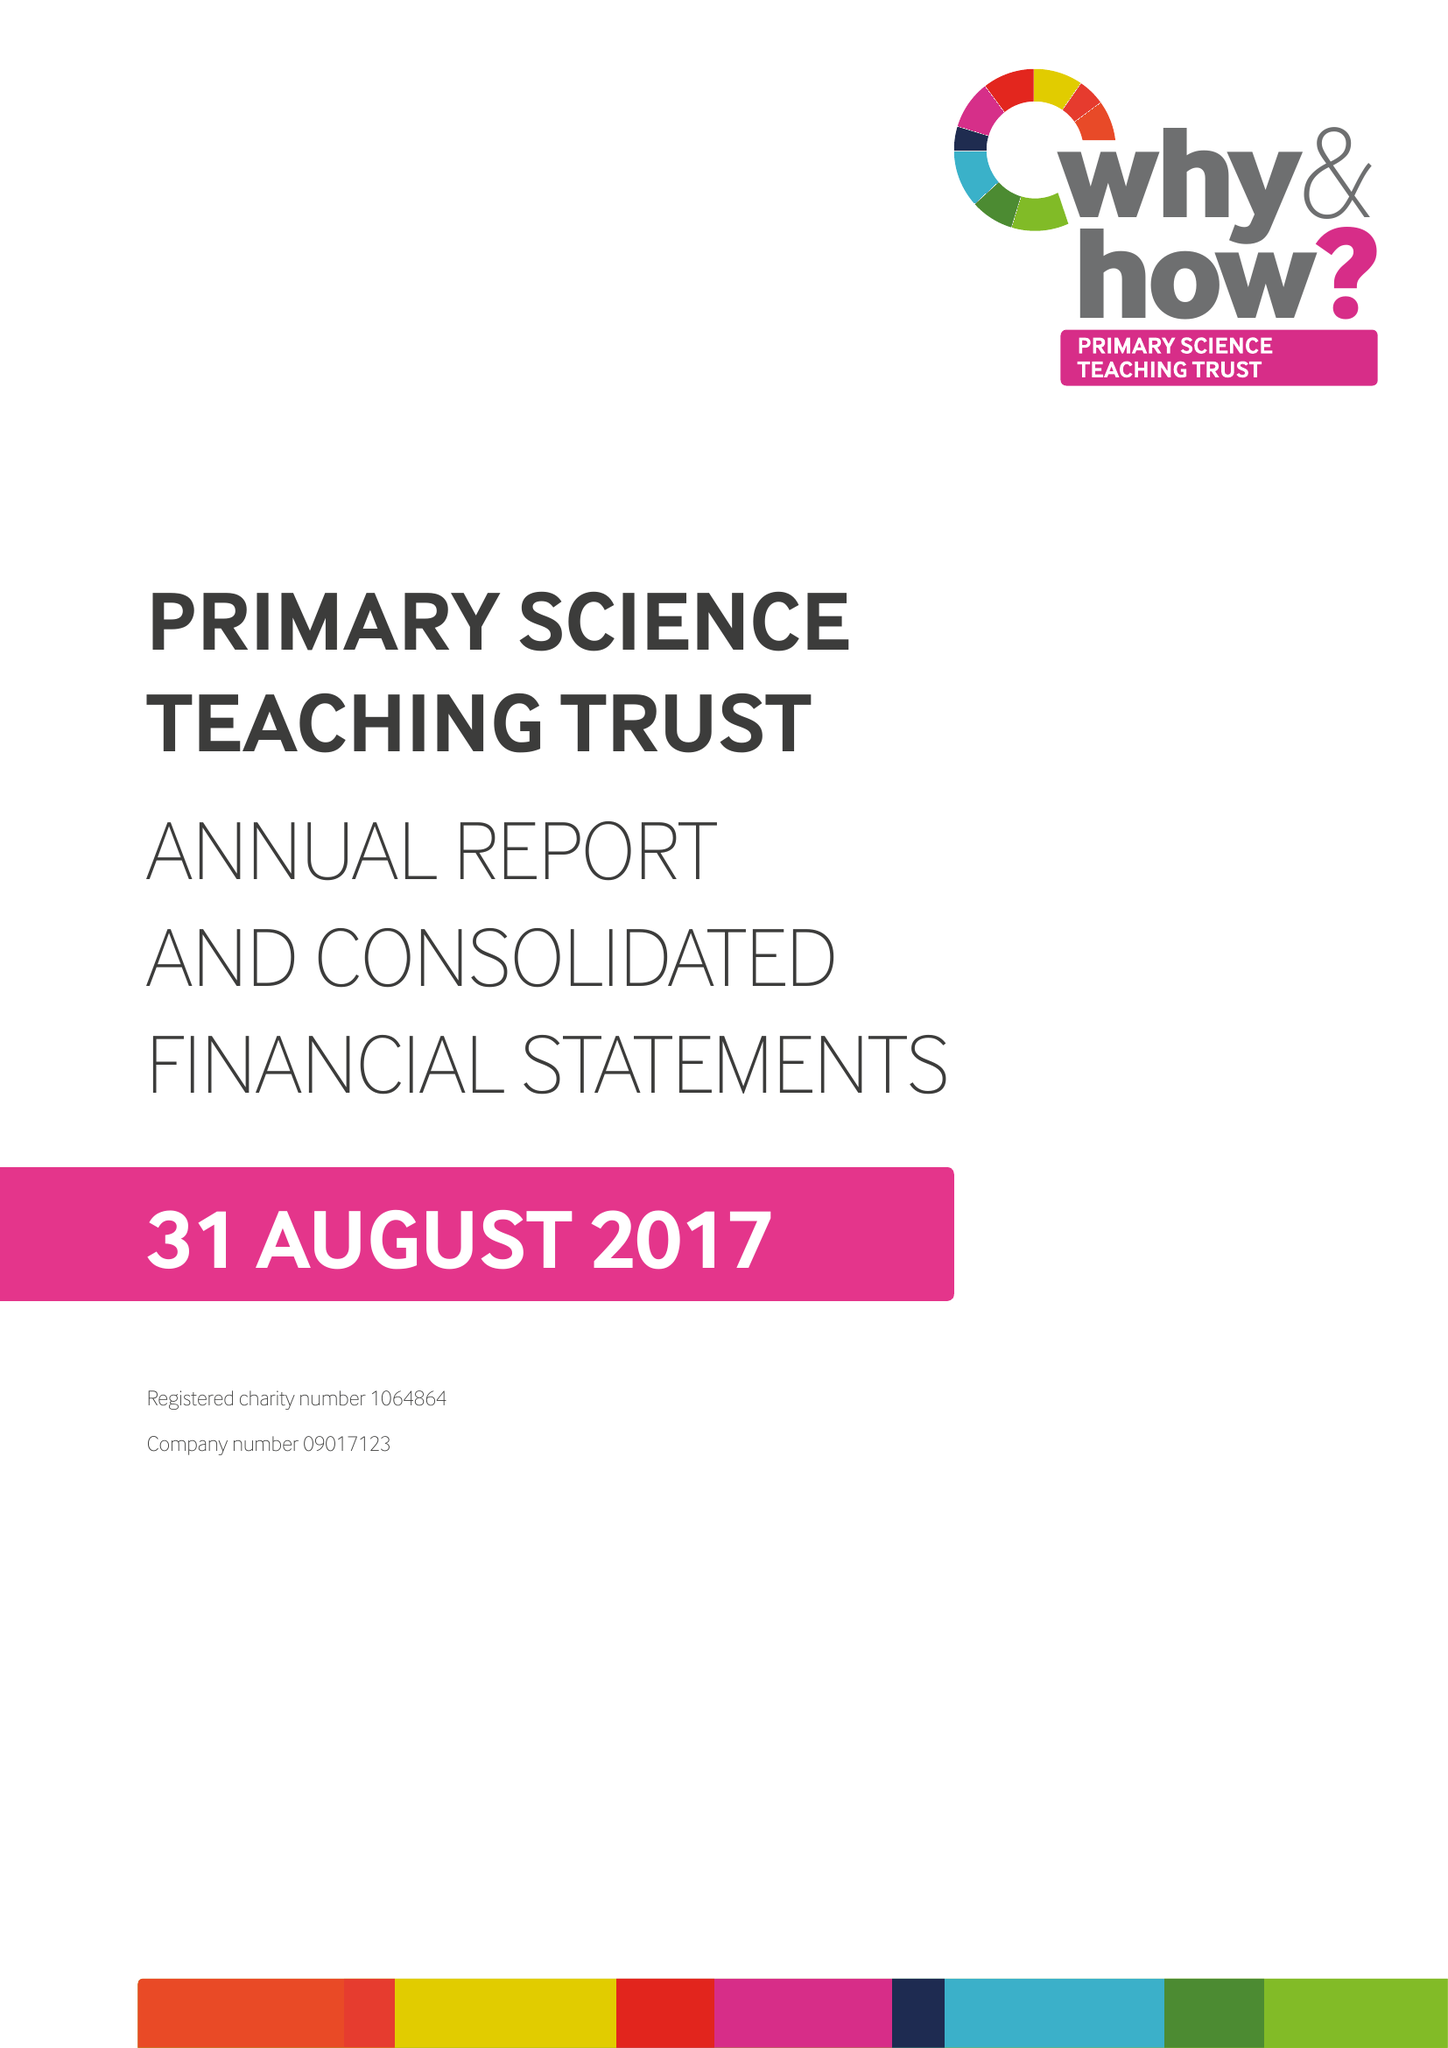What is the value for the charity_number?
Answer the question using a single word or phrase. 1064864 